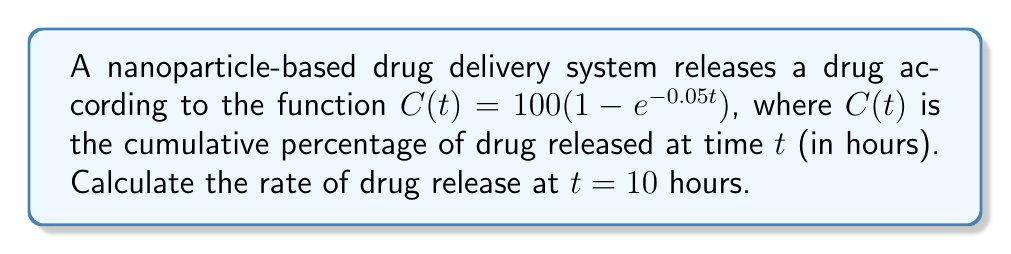Can you answer this question? To solve this problem, we need to follow these steps:

1) The rate of drug release is given by the derivative of the cumulative drug release function $C(t)$.

2) Let's find the derivative of $C(t)$:
   
   $$\frac{d}{dt}C(t) = \frac{d}{dt}[100(1 - e^{-0.05t})]$$
   
   Using the chain rule:
   
   $$\frac{d}{dt}C(t) = 100 \cdot \frac{d}{dt}[1 - e^{-0.05t}]$$
   $$\frac{d}{dt}C(t) = 100 \cdot [-(-0.05)e^{-0.05t}]$$
   $$\frac{d}{dt}C(t) = 5e^{-0.05t}$$

3) This derivative represents the rate of drug release at any time $t$.

4) To find the rate at $t = 10$ hours, we substitute $t = 10$ into our derivative:

   $$\left.\frac{d}{dt}C(t)\right|_{t=10} = 5e^{-0.05(10)}$$
   $$= 5e^{-0.5}$$
   $$\approx 3.03$$

5) Therefore, the rate of drug release at $t = 10$ hours is approximately 3.03% per hour.
Answer: $3.03\%$ per hour 